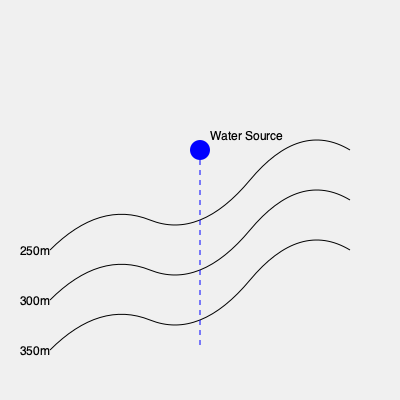Given the topographic map with contour lines and a water source, which irrigation method would be most efficient for uniform water distribution across the sloped terrain? To determine the most efficient irrigation method for this terrain, we need to consider the following factors:

1. Topography: The contour lines indicate a sloped terrain, with elevation decreasing from left to right.

2. Water source location: The water source is located at the highest point of the visible area.

3. Uniform distribution: We need a method that can distribute water evenly across the slope.

4. Efficiency: The method should minimize water loss and energy consumption.

Considering these factors:

1. Flood irrigation would be inefficient as water would flow rapidly downhill, causing erosion and uneven distribution.

2. Sprinkler irrigation might work but would be less efficient due to water loss from evaporation and wind drift on the sloped terrain.

3. Drip irrigation would be challenging to implement uniformly on a slope and may not provide adequate coverage for larger areas.

4. Contour furrow irrigation follows the natural contours of the land, which matches the topography shown in the map.

5. Center pivot irrigation would not be suitable due to the uneven terrain.

The most efficient method for this terrain would be contour furrow irrigation. This method involves creating furrows that follow the contour lines of the slope. Water is released from the source and flows through these furrows, allowing for:

- Even distribution of water across the slope
- Reduced erosion as water flow is controlled
- Efficient use of gravity to distribute water
- Minimal energy requirements for water distribution
- Reduced water loss compared to other methods

Contour furrow irrigation aligns perfectly with the contour lines shown in the topographic map, making it the most suitable and efficient choice for this terrain.
Answer: Contour furrow irrigation 